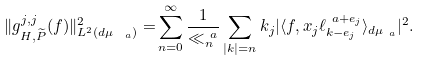<formula> <loc_0><loc_0><loc_500><loc_500>\| g _ { H , \widetilde { P } } ^ { j , j } ( f ) \| ^ { 2 } _ { L ^ { 2 } ( d \mu _ { \ a } ) } = & \sum _ { n = 0 } ^ { \infty } \frac { 1 } { \ll _ { n } ^ { \ a } } \sum _ { | k | = n } k _ { j } | \langle f , x _ { j } \ell _ { k - e _ { j } } ^ { \ a + e _ { j } } \rangle _ { d \mu _ { \ a } } | ^ { 2 } .</formula> 